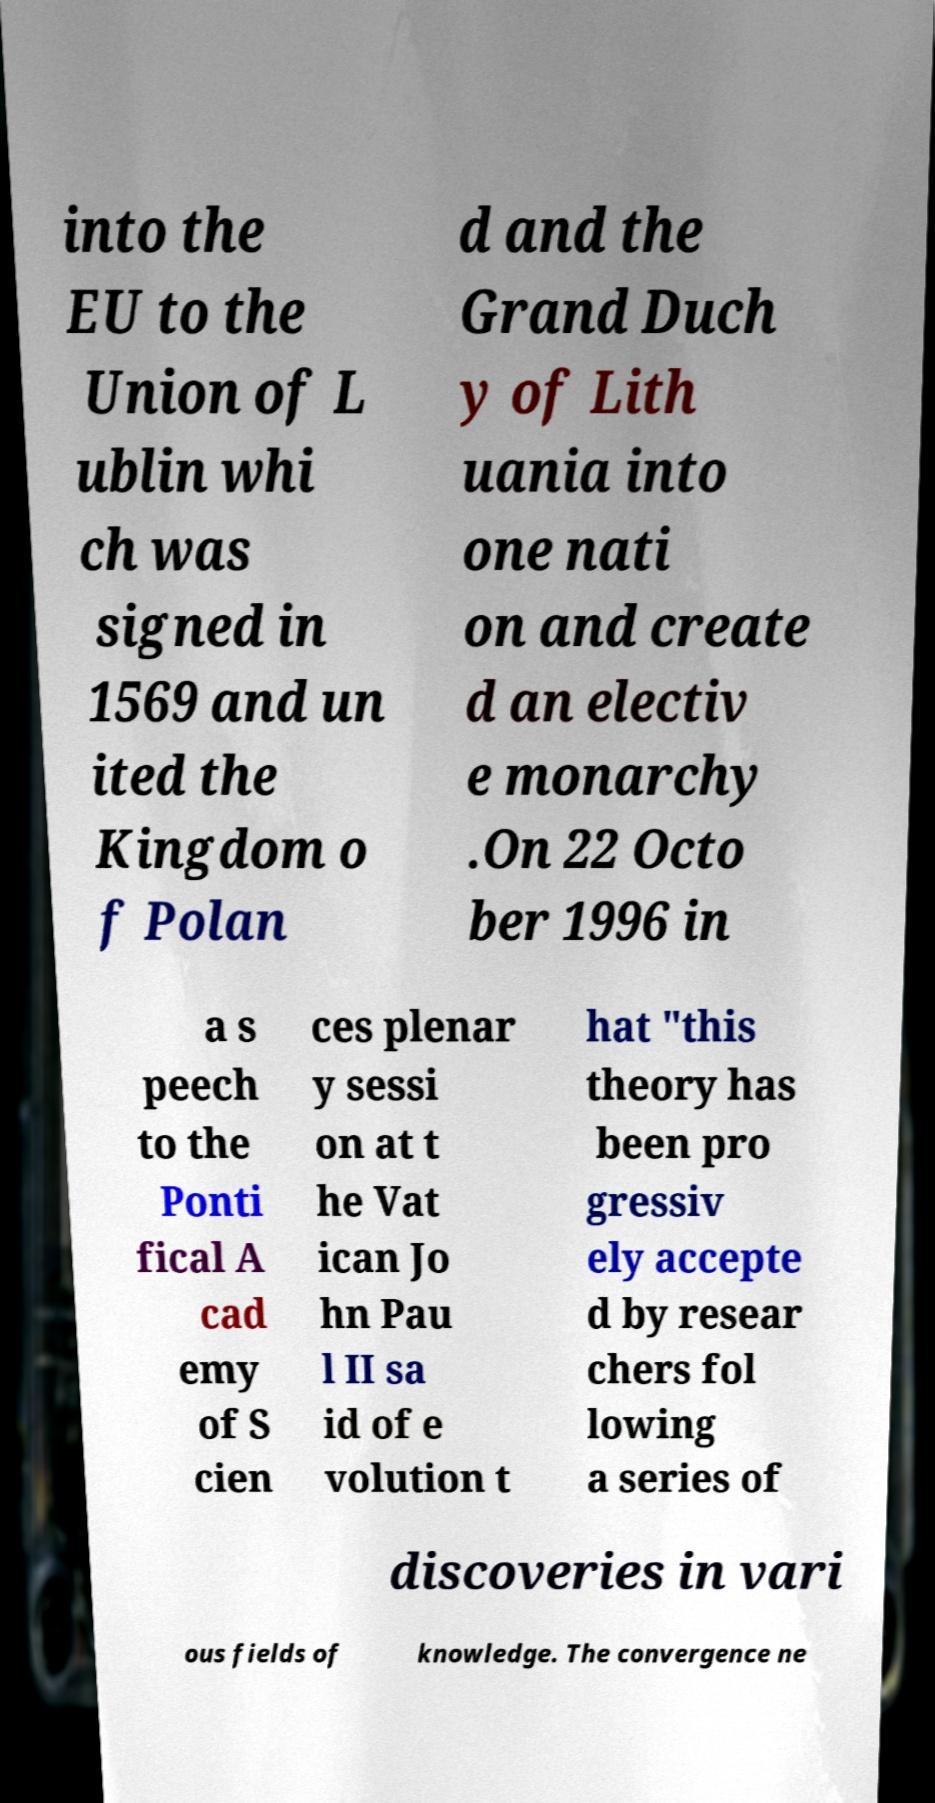Please identify and transcribe the text found in this image. into the EU to the Union of L ublin whi ch was signed in 1569 and un ited the Kingdom o f Polan d and the Grand Duch y of Lith uania into one nati on and create d an electiv e monarchy .On 22 Octo ber 1996 in a s peech to the Ponti fical A cad emy of S cien ces plenar y sessi on at t he Vat ican Jo hn Pau l II sa id of e volution t hat "this theory has been pro gressiv ely accepte d by resear chers fol lowing a series of discoveries in vari ous fields of knowledge. The convergence ne 